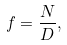Convert formula to latex. <formula><loc_0><loc_0><loc_500><loc_500>f = \frac { N } { D } ,</formula> 